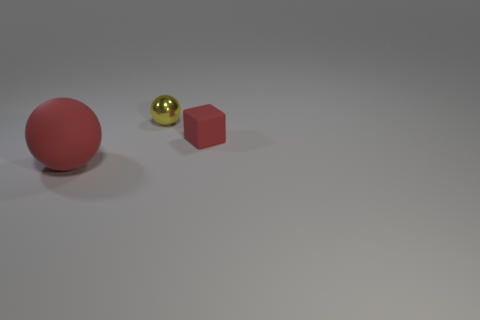Subtract all red spheres. How many spheres are left? 1 Subtract all red spheres. How many blue blocks are left? 0 Add 2 cyan shiny cubes. How many objects exist? 5 Subtract all blocks. How many objects are left? 2 Subtract all green balls. Subtract all cyan cylinders. How many balls are left? 2 Subtract all big gray metal spheres. Subtract all red matte blocks. How many objects are left? 2 Add 2 blocks. How many blocks are left? 3 Add 2 metal things. How many metal things exist? 3 Subtract 0 blue cubes. How many objects are left? 3 